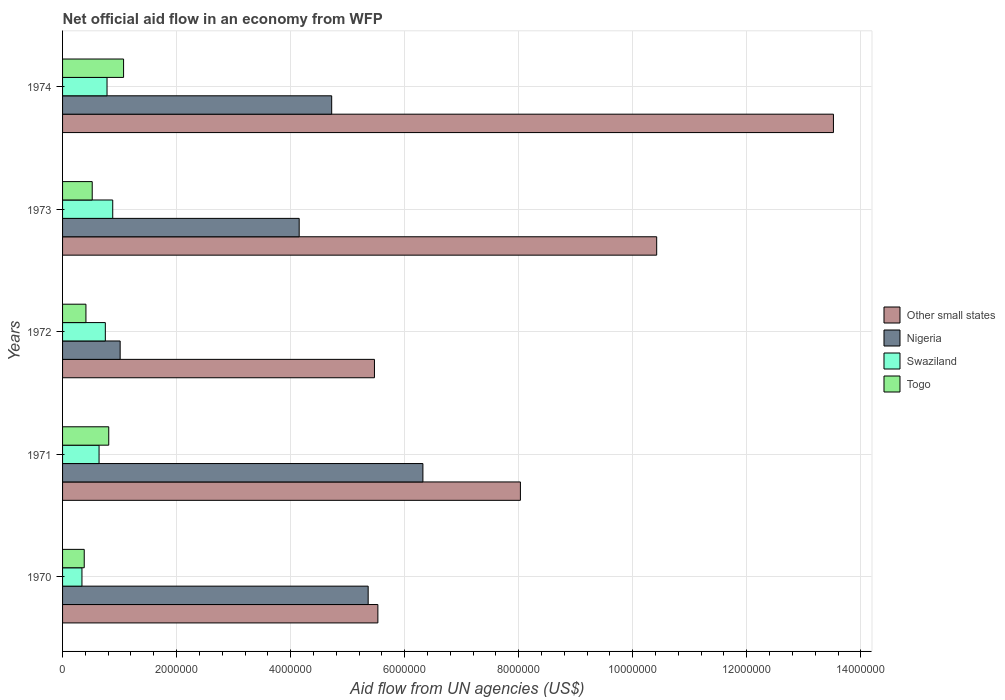How many different coloured bars are there?
Provide a short and direct response. 4. Are the number of bars on each tick of the Y-axis equal?
Make the answer very short. Yes. What is the label of the 1st group of bars from the top?
Make the answer very short. 1974. What is the net official aid flow in Swaziland in 1972?
Make the answer very short. 7.50e+05. Across all years, what is the maximum net official aid flow in Nigeria?
Your answer should be very brief. 6.32e+06. What is the total net official aid flow in Other small states in the graph?
Give a very brief answer. 4.30e+07. What is the difference between the net official aid flow in Togo in 1970 and that in 1971?
Provide a succinct answer. -4.30e+05. What is the difference between the net official aid flow in Nigeria in 1974 and the net official aid flow in Other small states in 1972?
Make the answer very short. -7.50e+05. What is the average net official aid flow in Nigeria per year?
Provide a short and direct response. 4.31e+06. In the year 1971, what is the difference between the net official aid flow in Nigeria and net official aid flow in Togo?
Keep it short and to the point. 5.51e+06. What is the ratio of the net official aid flow in Other small states in 1971 to that in 1972?
Your answer should be very brief. 1.47. What is the difference between the highest and the second highest net official aid flow in Other small states?
Provide a short and direct response. 3.10e+06. What is the difference between the highest and the lowest net official aid flow in Nigeria?
Give a very brief answer. 5.31e+06. In how many years, is the net official aid flow in Swaziland greater than the average net official aid flow in Swaziland taken over all years?
Provide a short and direct response. 3. What does the 4th bar from the top in 1974 represents?
Provide a succinct answer. Other small states. What does the 3rd bar from the bottom in 1972 represents?
Offer a terse response. Swaziland. Is it the case that in every year, the sum of the net official aid flow in Swaziland and net official aid flow in Nigeria is greater than the net official aid flow in Other small states?
Give a very brief answer. No. Does the graph contain grids?
Make the answer very short. Yes. Where does the legend appear in the graph?
Your answer should be compact. Center right. How many legend labels are there?
Offer a very short reply. 4. How are the legend labels stacked?
Your answer should be very brief. Vertical. What is the title of the graph?
Provide a succinct answer. Net official aid flow in an economy from WFP. What is the label or title of the X-axis?
Your answer should be compact. Aid flow from UN agencies (US$). What is the label or title of the Y-axis?
Your answer should be compact. Years. What is the Aid flow from UN agencies (US$) in Other small states in 1970?
Make the answer very short. 5.53e+06. What is the Aid flow from UN agencies (US$) of Nigeria in 1970?
Give a very brief answer. 5.36e+06. What is the Aid flow from UN agencies (US$) in Togo in 1970?
Your answer should be very brief. 3.80e+05. What is the Aid flow from UN agencies (US$) of Other small states in 1971?
Provide a succinct answer. 8.03e+06. What is the Aid flow from UN agencies (US$) in Nigeria in 1971?
Ensure brevity in your answer.  6.32e+06. What is the Aid flow from UN agencies (US$) in Swaziland in 1971?
Provide a short and direct response. 6.40e+05. What is the Aid flow from UN agencies (US$) of Togo in 1971?
Make the answer very short. 8.10e+05. What is the Aid flow from UN agencies (US$) of Other small states in 1972?
Ensure brevity in your answer.  5.47e+06. What is the Aid flow from UN agencies (US$) in Nigeria in 1972?
Offer a terse response. 1.01e+06. What is the Aid flow from UN agencies (US$) of Swaziland in 1972?
Offer a terse response. 7.50e+05. What is the Aid flow from UN agencies (US$) in Togo in 1972?
Offer a very short reply. 4.10e+05. What is the Aid flow from UN agencies (US$) in Other small states in 1973?
Offer a terse response. 1.04e+07. What is the Aid flow from UN agencies (US$) of Nigeria in 1973?
Give a very brief answer. 4.15e+06. What is the Aid flow from UN agencies (US$) in Swaziland in 1973?
Your answer should be very brief. 8.80e+05. What is the Aid flow from UN agencies (US$) of Togo in 1973?
Keep it short and to the point. 5.20e+05. What is the Aid flow from UN agencies (US$) in Other small states in 1974?
Make the answer very short. 1.35e+07. What is the Aid flow from UN agencies (US$) in Nigeria in 1974?
Offer a very short reply. 4.72e+06. What is the Aid flow from UN agencies (US$) of Swaziland in 1974?
Your response must be concise. 7.80e+05. What is the Aid flow from UN agencies (US$) in Togo in 1974?
Your answer should be very brief. 1.07e+06. Across all years, what is the maximum Aid flow from UN agencies (US$) in Other small states?
Offer a terse response. 1.35e+07. Across all years, what is the maximum Aid flow from UN agencies (US$) of Nigeria?
Provide a succinct answer. 6.32e+06. Across all years, what is the maximum Aid flow from UN agencies (US$) in Swaziland?
Keep it short and to the point. 8.80e+05. Across all years, what is the maximum Aid flow from UN agencies (US$) of Togo?
Give a very brief answer. 1.07e+06. Across all years, what is the minimum Aid flow from UN agencies (US$) of Other small states?
Ensure brevity in your answer.  5.47e+06. Across all years, what is the minimum Aid flow from UN agencies (US$) in Nigeria?
Your answer should be compact. 1.01e+06. Across all years, what is the minimum Aid flow from UN agencies (US$) of Swaziland?
Offer a very short reply. 3.40e+05. Across all years, what is the minimum Aid flow from UN agencies (US$) of Togo?
Your response must be concise. 3.80e+05. What is the total Aid flow from UN agencies (US$) of Other small states in the graph?
Provide a short and direct response. 4.30e+07. What is the total Aid flow from UN agencies (US$) in Nigeria in the graph?
Your response must be concise. 2.16e+07. What is the total Aid flow from UN agencies (US$) in Swaziland in the graph?
Provide a succinct answer. 3.39e+06. What is the total Aid flow from UN agencies (US$) of Togo in the graph?
Your answer should be very brief. 3.19e+06. What is the difference between the Aid flow from UN agencies (US$) in Other small states in 1970 and that in 1971?
Ensure brevity in your answer.  -2.50e+06. What is the difference between the Aid flow from UN agencies (US$) in Nigeria in 1970 and that in 1971?
Your answer should be compact. -9.60e+05. What is the difference between the Aid flow from UN agencies (US$) of Swaziland in 1970 and that in 1971?
Provide a succinct answer. -3.00e+05. What is the difference between the Aid flow from UN agencies (US$) in Togo in 1970 and that in 1971?
Give a very brief answer. -4.30e+05. What is the difference between the Aid flow from UN agencies (US$) of Nigeria in 1970 and that in 1972?
Keep it short and to the point. 4.35e+06. What is the difference between the Aid flow from UN agencies (US$) of Swaziland in 1970 and that in 1972?
Offer a terse response. -4.10e+05. What is the difference between the Aid flow from UN agencies (US$) of Togo in 1970 and that in 1972?
Give a very brief answer. -3.00e+04. What is the difference between the Aid flow from UN agencies (US$) of Other small states in 1970 and that in 1973?
Keep it short and to the point. -4.89e+06. What is the difference between the Aid flow from UN agencies (US$) of Nigeria in 1970 and that in 1973?
Ensure brevity in your answer.  1.21e+06. What is the difference between the Aid flow from UN agencies (US$) of Swaziland in 1970 and that in 1973?
Make the answer very short. -5.40e+05. What is the difference between the Aid flow from UN agencies (US$) in Other small states in 1970 and that in 1974?
Make the answer very short. -7.99e+06. What is the difference between the Aid flow from UN agencies (US$) of Nigeria in 1970 and that in 1974?
Make the answer very short. 6.40e+05. What is the difference between the Aid flow from UN agencies (US$) of Swaziland in 1970 and that in 1974?
Make the answer very short. -4.40e+05. What is the difference between the Aid flow from UN agencies (US$) in Togo in 1970 and that in 1974?
Give a very brief answer. -6.90e+05. What is the difference between the Aid flow from UN agencies (US$) in Other small states in 1971 and that in 1972?
Your answer should be very brief. 2.56e+06. What is the difference between the Aid flow from UN agencies (US$) of Nigeria in 1971 and that in 1972?
Keep it short and to the point. 5.31e+06. What is the difference between the Aid flow from UN agencies (US$) of Other small states in 1971 and that in 1973?
Provide a short and direct response. -2.39e+06. What is the difference between the Aid flow from UN agencies (US$) of Nigeria in 1971 and that in 1973?
Your answer should be very brief. 2.17e+06. What is the difference between the Aid flow from UN agencies (US$) of Swaziland in 1971 and that in 1973?
Give a very brief answer. -2.40e+05. What is the difference between the Aid flow from UN agencies (US$) in Togo in 1971 and that in 1973?
Provide a short and direct response. 2.90e+05. What is the difference between the Aid flow from UN agencies (US$) of Other small states in 1971 and that in 1974?
Provide a succinct answer. -5.49e+06. What is the difference between the Aid flow from UN agencies (US$) of Nigeria in 1971 and that in 1974?
Offer a terse response. 1.60e+06. What is the difference between the Aid flow from UN agencies (US$) in Other small states in 1972 and that in 1973?
Give a very brief answer. -4.95e+06. What is the difference between the Aid flow from UN agencies (US$) of Nigeria in 1972 and that in 1973?
Your answer should be compact. -3.14e+06. What is the difference between the Aid flow from UN agencies (US$) in Swaziland in 1972 and that in 1973?
Offer a very short reply. -1.30e+05. What is the difference between the Aid flow from UN agencies (US$) of Other small states in 1972 and that in 1974?
Keep it short and to the point. -8.05e+06. What is the difference between the Aid flow from UN agencies (US$) of Nigeria in 1972 and that in 1974?
Offer a very short reply. -3.71e+06. What is the difference between the Aid flow from UN agencies (US$) in Togo in 1972 and that in 1974?
Your response must be concise. -6.60e+05. What is the difference between the Aid flow from UN agencies (US$) in Other small states in 1973 and that in 1974?
Your response must be concise. -3.10e+06. What is the difference between the Aid flow from UN agencies (US$) of Nigeria in 1973 and that in 1974?
Your answer should be very brief. -5.70e+05. What is the difference between the Aid flow from UN agencies (US$) in Swaziland in 1973 and that in 1974?
Provide a short and direct response. 1.00e+05. What is the difference between the Aid flow from UN agencies (US$) of Togo in 1973 and that in 1974?
Your answer should be very brief. -5.50e+05. What is the difference between the Aid flow from UN agencies (US$) in Other small states in 1970 and the Aid flow from UN agencies (US$) in Nigeria in 1971?
Make the answer very short. -7.90e+05. What is the difference between the Aid flow from UN agencies (US$) in Other small states in 1970 and the Aid flow from UN agencies (US$) in Swaziland in 1971?
Your response must be concise. 4.89e+06. What is the difference between the Aid flow from UN agencies (US$) in Other small states in 1970 and the Aid flow from UN agencies (US$) in Togo in 1971?
Keep it short and to the point. 4.72e+06. What is the difference between the Aid flow from UN agencies (US$) of Nigeria in 1970 and the Aid flow from UN agencies (US$) of Swaziland in 1971?
Make the answer very short. 4.72e+06. What is the difference between the Aid flow from UN agencies (US$) of Nigeria in 1970 and the Aid flow from UN agencies (US$) of Togo in 1971?
Offer a terse response. 4.55e+06. What is the difference between the Aid flow from UN agencies (US$) in Swaziland in 1970 and the Aid flow from UN agencies (US$) in Togo in 1971?
Provide a succinct answer. -4.70e+05. What is the difference between the Aid flow from UN agencies (US$) in Other small states in 1970 and the Aid flow from UN agencies (US$) in Nigeria in 1972?
Your answer should be compact. 4.52e+06. What is the difference between the Aid flow from UN agencies (US$) in Other small states in 1970 and the Aid flow from UN agencies (US$) in Swaziland in 1972?
Ensure brevity in your answer.  4.78e+06. What is the difference between the Aid flow from UN agencies (US$) of Other small states in 1970 and the Aid flow from UN agencies (US$) of Togo in 1972?
Make the answer very short. 5.12e+06. What is the difference between the Aid flow from UN agencies (US$) of Nigeria in 1970 and the Aid flow from UN agencies (US$) of Swaziland in 1972?
Provide a short and direct response. 4.61e+06. What is the difference between the Aid flow from UN agencies (US$) of Nigeria in 1970 and the Aid flow from UN agencies (US$) of Togo in 1972?
Offer a terse response. 4.95e+06. What is the difference between the Aid flow from UN agencies (US$) of Other small states in 1970 and the Aid flow from UN agencies (US$) of Nigeria in 1973?
Give a very brief answer. 1.38e+06. What is the difference between the Aid flow from UN agencies (US$) of Other small states in 1970 and the Aid flow from UN agencies (US$) of Swaziland in 1973?
Provide a short and direct response. 4.65e+06. What is the difference between the Aid flow from UN agencies (US$) in Other small states in 1970 and the Aid flow from UN agencies (US$) in Togo in 1973?
Provide a short and direct response. 5.01e+06. What is the difference between the Aid flow from UN agencies (US$) in Nigeria in 1970 and the Aid flow from UN agencies (US$) in Swaziland in 1973?
Make the answer very short. 4.48e+06. What is the difference between the Aid flow from UN agencies (US$) of Nigeria in 1970 and the Aid flow from UN agencies (US$) of Togo in 1973?
Give a very brief answer. 4.84e+06. What is the difference between the Aid flow from UN agencies (US$) of Other small states in 1970 and the Aid flow from UN agencies (US$) of Nigeria in 1974?
Provide a succinct answer. 8.10e+05. What is the difference between the Aid flow from UN agencies (US$) of Other small states in 1970 and the Aid flow from UN agencies (US$) of Swaziland in 1974?
Offer a very short reply. 4.75e+06. What is the difference between the Aid flow from UN agencies (US$) of Other small states in 1970 and the Aid flow from UN agencies (US$) of Togo in 1974?
Provide a short and direct response. 4.46e+06. What is the difference between the Aid flow from UN agencies (US$) of Nigeria in 1970 and the Aid flow from UN agencies (US$) of Swaziland in 1974?
Ensure brevity in your answer.  4.58e+06. What is the difference between the Aid flow from UN agencies (US$) of Nigeria in 1970 and the Aid flow from UN agencies (US$) of Togo in 1974?
Keep it short and to the point. 4.29e+06. What is the difference between the Aid flow from UN agencies (US$) of Swaziland in 1970 and the Aid flow from UN agencies (US$) of Togo in 1974?
Keep it short and to the point. -7.30e+05. What is the difference between the Aid flow from UN agencies (US$) in Other small states in 1971 and the Aid flow from UN agencies (US$) in Nigeria in 1972?
Give a very brief answer. 7.02e+06. What is the difference between the Aid flow from UN agencies (US$) in Other small states in 1971 and the Aid flow from UN agencies (US$) in Swaziland in 1972?
Your answer should be compact. 7.28e+06. What is the difference between the Aid flow from UN agencies (US$) in Other small states in 1971 and the Aid flow from UN agencies (US$) in Togo in 1972?
Provide a short and direct response. 7.62e+06. What is the difference between the Aid flow from UN agencies (US$) of Nigeria in 1971 and the Aid flow from UN agencies (US$) of Swaziland in 1972?
Keep it short and to the point. 5.57e+06. What is the difference between the Aid flow from UN agencies (US$) in Nigeria in 1971 and the Aid flow from UN agencies (US$) in Togo in 1972?
Provide a short and direct response. 5.91e+06. What is the difference between the Aid flow from UN agencies (US$) in Other small states in 1971 and the Aid flow from UN agencies (US$) in Nigeria in 1973?
Give a very brief answer. 3.88e+06. What is the difference between the Aid flow from UN agencies (US$) of Other small states in 1971 and the Aid flow from UN agencies (US$) of Swaziland in 1973?
Provide a short and direct response. 7.15e+06. What is the difference between the Aid flow from UN agencies (US$) in Other small states in 1971 and the Aid flow from UN agencies (US$) in Togo in 1973?
Your response must be concise. 7.51e+06. What is the difference between the Aid flow from UN agencies (US$) of Nigeria in 1971 and the Aid flow from UN agencies (US$) of Swaziland in 1973?
Provide a short and direct response. 5.44e+06. What is the difference between the Aid flow from UN agencies (US$) of Nigeria in 1971 and the Aid flow from UN agencies (US$) of Togo in 1973?
Ensure brevity in your answer.  5.80e+06. What is the difference between the Aid flow from UN agencies (US$) in Swaziland in 1971 and the Aid flow from UN agencies (US$) in Togo in 1973?
Ensure brevity in your answer.  1.20e+05. What is the difference between the Aid flow from UN agencies (US$) of Other small states in 1971 and the Aid flow from UN agencies (US$) of Nigeria in 1974?
Offer a very short reply. 3.31e+06. What is the difference between the Aid flow from UN agencies (US$) of Other small states in 1971 and the Aid flow from UN agencies (US$) of Swaziland in 1974?
Make the answer very short. 7.25e+06. What is the difference between the Aid flow from UN agencies (US$) in Other small states in 1971 and the Aid flow from UN agencies (US$) in Togo in 1974?
Make the answer very short. 6.96e+06. What is the difference between the Aid flow from UN agencies (US$) of Nigeria in 1971 and the Aid flow from UN agencies (US$) of Swaziland in 1974?
Make the answer very short. 5.54e+06. What is the difference between the Aid flow from UN agencies (US$) of Nigeria in 1971 and the Aid flow from UN agencies (US$) of Togo in 1974?
Provide a succinct answer. 5.25e+06. What is the difference between the Aid flow from UN agencies (US$) of Swaziland in 1971 and the Aid flow from UN agencies (US$) of Togo in 1974?
Keep it short and to the point. -4.30e+05. What is the difference between the Aid flow from UN agencies (US$) of Other small states in 1972 and the Aid flow from UN agencies (US$) of Nigeria in 1973?
Provide a succinct answer. 1.32e+06. What is the difference between the Aid flow from UN agencies (US$) in Other small states in 1972 and the Aid flow from UN agencies (US$) in Swaziland in 1973?
Ensure brevity in your answer.  4.59e+06. What is the difference between the Aid flow from UN agencies (US$) in Other small states in 1972 and the Aid flow from UN agencies (US$) in Togo in 1973?
Your answer should be very brief. 4.95e+06. What is the difference between the Aid flow from UN agencies (US$) of Nigeria in 1972 and the Aid flow from UN agencies (US$) of Swaziland in 1973?
Your answer should be very brief. 1.30e+05. What is the difference between the Aid flow from UN agencies (US$) in Nigeria in 1972 and the Aid flow from UN agencies (US$) in Togo in 1973?
Keep it short and to the point. 4.90e+05. What is the difference between the Aid flow from UN agencies (US$) of Other small states in 1972 and the Aid flow from UN agencies (US$) of Nigeria in 1974?
Ensure brevity in your answer.  7.50e+05. What is the difference between the Aid flow from UN agencies (US$) of Other small states in 1972 and the Aid flow from UN agencies (US$) of Swaziland in 1974?
Provide a succinct answer. 4.69e+06. What is the difference between the Aid flow from UN agencies (US$) in Other small states in 1972 and the Aid flow from UN agencies (US$) in Togo in 1974?
Provide a succinct answer. 4.40e+06. What is the difference between the Aid flow from UN agencies (US$) of Nigeria in 1972 and the Aid flow from UN agencies (US$) of Togo in 1974?
Ensure brevity in your answer.  -6.00e+04. What is the difference between the Aid flow from UN agencies (US$) of Swaziland in 1972 and the Aid flow from UN agencies (US$) of Togo in 1974?
Your response must be concise. -3.20e+05. What is the difference between the Aid flow from UN agencies (US$) in Other small states in 1973 and the Aid flow from UN agencies (US$) in Nigeria in 1974?
Your response must be concise. 5.70e+06. What is the difference between the Aid flow from UN agencies (US$) of Other small states in 1973 and the Aid flow from UN agencies (US$) of Swaziland in 1974?
Ensure brevity in your answer.  9.64e+06. What is the difference between the Aid flow from UN agencies (US$) of Other small states in 1973 and the Aid flow from UN agencies (US$) of Togo in 1974?
Give a very brief answer. 9.35e+06. What is the difference between the Aid flow from UN agencies (US$) in Nigeria in 1973 and the Aid flow from UN agencies (US$) in Swaziland in 1974?
Provide a short and direct response. 3.37e+06. What is the difference between the Aid flow from UN agencies (US$) of Nigeria in 1973 and the Aid flow from UN agencies (US$) of Togo in 1974?
Offer a terse response. 3.08e+06. What is the difference between the Aid flow from UN agencies (US$) of Swaziland in 1973 and the Aid flow from UN agencies (US$) of Togo in 1974?
Ensure brevity in your answer.  -1.90e+05. What is the average Aid flow from UN agencies (US$) of Other small states per year?
Give a very brief answer. 8.59e+06. What is the average Aid flow from UN agencies (US$) in Nigeria per year?
Your answer should be very brief. 4.31e+06. What is the average Aid flow from UN agencies (US$) of Swaziland per year?
Make the answer very short. 6.78e+05. What is the average Aid flow from UN agencies (US$) of Togo per year?
Keep it short and to the point. 6.38e+05. In the year 1970, what is the difference between the Aid flow from UN agencies (US$) in Other small states and Aid flow from UN agencies (US$) in Nigeria?
Your answer should be very brief. 1.70e+05. In the year 1970, what is the difference between the Aid flow from UN agencies (US$) of Other small states and Aid flow from UN agencies (US$) of Swaziland?
Provide a short and direct response. 5.19e+06. In the year 1970, what is the difference between the Aid flow from UN agencies (US$) of Other small states and Aid flow from UN agencies (US$) of Togo?
Make the answer very short. 5.15e+06. In the year 1970, what is the difference between the Aid flow from UN agencies (US$) in Nigeria and Aid flow from UN agencies (US$) in Swaziland?
Your answer should be compact. 5.02e+06. In the year 1970, what is the difference between the Aid flow from UN agencies (US$) in Nigeria and Aid flow from UN agencies (US$) in Togo?
Your response must be concise. 4.98e+06. In the year 1970, what is the difference between the Aid flow from UN agencies (US$) of Swaziland and Aid flow from UN agencies (US$) of Togo?
Provide a succinct answer. -4.00e+04. In the year 1971, what is the difference between the Aid flow from UN agencies (US$) in Other small states and Aid flow from UN agencies (US$) in Nigeria?
Ensure brevity in your answer.  1.71e+06. In the year 1971, what is the difference between the Aid flow from UN agencies (US$) in Other small states and Aid flow from UN agencies (US$) in Swaziland?
Provide a short and direct response. 7.39e+06. In the year 1971, what is the difference between the Aid flow from UN agencies (US$) in Other small states and Aid flow from UN agencies (US$) in Togo?
Provide a succinct answer. 7.22e+06. In the year 1971, what is the difference between the Aid flow from UN agencies (US$) in Nigeria and Aid flow from UN agencies (US$) in Swaziland?
Provide a succinct answer. 5.68e+06. In the year 1971, what is the difference between the Aid flow from UN agencies (US$) in Nigeria and Aid flow from UN agencies (US$) in Togo?
Your answer should be compact. 5.51e+06. In the year 1972, what is the difference between the Aid flow from UN agencies (US$) in Other small states and Aid flow from UN agencies (US$) in Nigeria?
Provide a short and direct response. 4.46e+06. In the year 1972, what is the difference between the Aid flow from UN agencies (US$) in Other small states and Aid flow from UN agencies (US$) in Swaziland?
Give a very brief answer. 4.72e+06. In the year 1972, what is the difference between the Aid flow from UN agencies (US$) of Other small states and Aid flow from UN agencies (US$) of Togo?
Provide a succinct answer. 5.06e+06. In the year 1972, what is the difference between the Aid flow from UN agencies (US$) of Nigeria and Aid flow from UN agencies (US$) of Swaziland?
Offer a terse response. 2.60e+05. In the year 1972, what is the difference between the Aid flow from UN agencies (US$) in Nigeria and Aid flow from UN agencies (US$) in Togo?
Provide a succinct answer. 6.00e+05. In the year 1973, what is the difference between the Aid flow from UN agencies (US$) in Other small states and Aid flow from UN agencies (US$) in Nigeria?
Keep it short and to the point. 6.27e+06. In the year 1973, what is the difference between the Aid flow from UN agencies (US$) in Other small states and Aid flow from UN agencies (US$) in Swaziland?
Give a very brief answer. 9.54e+06. In the year 1973, what is the difference between the Aid flow from UN agencies (US$) in Other small states and Aid flow from UN agencies (US$) in Togo?
Keep it short and to the point. 9.90e+06. In the year 1973, what is the difference between the Aid flow from UN agencies (US$) of Nigeria and Aid flow from UN agencies (US$) of Swaziland?
Give a very brief answer. 3.27e+06. In the year 1973, what is the difference between the Aid flow from UN agencies (US$) in Nigeria and Aid flow from UN agencies (US$) in Togo?
Offer a very short reply. 3.63e+06. In the year 1974, what is the difference between the Aid flow from UN agencies (US$) in Other small states and Aid flow from UN agencies (US$) in Nigeria?
Your answer should be compact. 8.80e+06. In the year 1974, what is the difference between the Aid flow from UN agencies (US$) of Other small states and Aid flow from UN agencies (US$) of Swaziland?
Provide a succinct answer. 1.27e+07. In the year 1974, what is the difference between the Aid flow from UN agencies (US$) in Other small states and Aid flow from UN agencies (US$) in Togo?
Ensure brevity in your answer.  1.24e+07. In the year 1974, what is the difference between the Aid flow from UN agencies (US$) of Nigeria and Aid flow from UN agencies (US$) of Swaziland?
Your response must be concise. 3.94e+06. In the year 1974, what is the difference between the Aid flow from UN agencies (US$) in Nigeria and Aid flow from UN agencies (US$) in Togo?
Your answer should be very brief. 3.65e+06. In the year 1974, what is the difference between the Aid flow from UN agencies (US$) of Swaziland and Aid flow from UN agencies (US$) of Togo?
Provide a succinct answer. -2.90e+05. What is the ratio of the Aid flow from UN agencies (US$) of Other small states in 1970 to that in 1971?
Give a very brief answer. 0.69. What is the ratio of the Aid flow from UN agencies (US$) in Nigeria in 1970 to that in 1971?
Your answer should be compact. 0.85. What is the ratio of the Aid flow from UN agencies (US$) of Swaziland in 1970 to that in 1971?
Offer a terse response. 0.53. What is the ratio of the Aid flow from UN agencies (US$) in Togo in 1970 to that in 1971?
Offer a very short reply. 0.47. What is the ratio of the Aid flow from UN agencies (US$) in Nigeria in 1970 to that in 1972?
Your response must be concise. 5.31. What is the ratio of the Aid flow from UN agencies (US$) in Swaziland in 1970 to that in 1972?
Make the answer very short. 0.45. What is the ratio of the Aid flow from UN agencies (US$) in Togo in 1970 to that in 1972?
Offer a very short reply. 0.93. What is the ratio of the Aid flow from UN agencies (US$) in Other small states in 1970 to that in 1973?
Your answer should be compact. 0.53. What is the ratio of the Aid flow from UN agencies (US$) in Nigeria in 1970 to that in 1973?
Offer a terse response. 1.29. What is the ratio of the Aid flow from UN agencies (US$) in Swaziland in 1970 to that in 1973?
Make the answer very short. 0.39. What is the ratio of the Aid flow from UN agencies (US$) of Togo in 1970 to that in 1973?
Make the answer very short. 0.73. What is the ratio of the Aid flow from UN agencies (US$) of Other small states in 1970 to that in 1974?
Provide a short and direct response. 0.41. What is the ratio of the Aid flow from UN agencies (US$) of Nigeria in 1970 to that in 1974?
Your answer should be compact. 1.14. What is the ratio of the Aid flow from UN agencies (US$) in Swaziland in 1970 to that in 1974?
Give a very brief answer. 0.44. What is the ratio of the Aid flow from UN agencies (US$) of Togo in 1970 to that in 1974?
Provide a succinct answer. 0.36. What is the ratio of the Aid flow from UN agencies (US$) of Other small states in 1971 to that in 1972?
Your answer should be compact. 1.47. What is the ratio of the Aid flow from UN agencies (US$) of Nigeria in 1971 to that in 1972?
Keep it short and to the point. 6.26. What is the ratio of the Aid flow from UN agencies (US$) of Swaziland in 1971 to that in 1972?
Ensure brevity in your answer.  0.85. What is the ratio of the Aid flow from UN agencies (US$) of Togo in 1971 to that in 1972?
Your answer should be very brief. 1.98. What is the ratio of the Aid flow from UN agencies (US$) in Other small states in 1971 to that in 1973?
Provide a short and direct response. 0.77. What is the ratio of the Aid flow from UN agencies (US$) in Nigeria in 1971 to that in 1973?
Your answer should be very brief. 1.52. What is the ratio of the Aid flow from UN agencies (US$) in Swaziland in 1971 to that in 1973?
Your answer should be very brief. 0.73. What is the ratio of the Aid flow from UN agencies (US$) of Togo in 1971 to that in 1973?
Make the answer very short. 1.56. What is the ratio of the Aid flow from UN agencies (US$) of Other small states in 1971 to that in 1974?
Your answer should be very brief. 0.59. What is the ratio of the Aid flow from UN agencies (US$) of Nigeria in 1971 to that in 1974?
Offer a terse response. 1.34. What is the ratio of the Aid flow from UN agencies (US$) of Swaziland in 1971 to that in 1974?
Keep it short and to the point. 0.82. What is the ratio of the Aid flow from UN agencies (US$) of Togo in 1971 to that in 1974?
Make the answer very short. 0.76. What is the ratio of the Aid flow from UN agencies (US$) of Other small states in 1972 to that in 1973?
Offer a very short reply. 0.53. What is the ratio of the Aid flow from UN agencies (US$) in Nigeria in 1972 to that in 1973?
Provide a short and direct response. 0.24. What is the ratio of the Aid flow from UN agencies (US$) in Swaziland in 1972 to that in 1973?
Your answer should be compact. 0.85. What is the ratio of the Aid flow from UN agencies (US$) of Togo in 1972 to that in 1973?
Keep it short and to the point. 0.79. What is the ratio of the Aid flow from UN agencies (US$) in Other small states in 1972 to that in 1974?
Make the answer very short. 0.4. What is the ratio of the Aid flow from UN agencies (US$) of Nigeria in 1972 to that in 1974?
Provide a short and direct response. 0.21. What is the ratio of the Aid flow from UN agencies (US$) of Swaziland in 1972 to that in 1974?
Give a very brief answer. 0.96. What is the ratio of the Aid flow from UN agencies (US$) in Togo in 1972 to that in 1974?
Your answer should be very brief. 0.38. What is the ratio of the Aid flow from UN agencies (US$) in Other small states in 1973 to that in 1974?
Keep it short and to the point. 0.77. What is the ratio of the Aid flow from UN agencies (US$) of Nigeria in 1973 to that in 1974?
Give a very brief answer. 0.88. What is the ratio of the Aid flow from UN agencies (US$) in Swaziland in 1973 to that in 1974?
Give a very brief answer. 1.13. What is the ratio of the Aid flow from UN agencies (US$) of Togo in 1973 to that in 1974?
Ensure brevity in your answer.  0.49. What is the difference between the highest and the second highest Aid flow from UN agencies (US$) of Other small states?
Keep it short and to the point. 3.10e+06. What is the difference between the highest and the second highest Aid flow from UN agencies (US$) of Nigeria?
Your answer should be very brief. 9.60e+05. What is the difference between the highest and the lowest Aid flow from UN agencies (US$) in Other small states?
Your answer should be compact. 8.05e+06. What is the difference between the highest and the lowest Aid flow from UN agencies (US$) of Nigeria?
Offer a terse response. 5.31e+06. What is the difference between the highest and the lowest Aid flow from UN agencies (US$) in Swaziland?
Your answer should be compact. 5.40e+05. What is the difference between the highest and the lowest Aid flow from UN agencies (US$) of Togo?
Your response must be concise. 6.90e+05. 